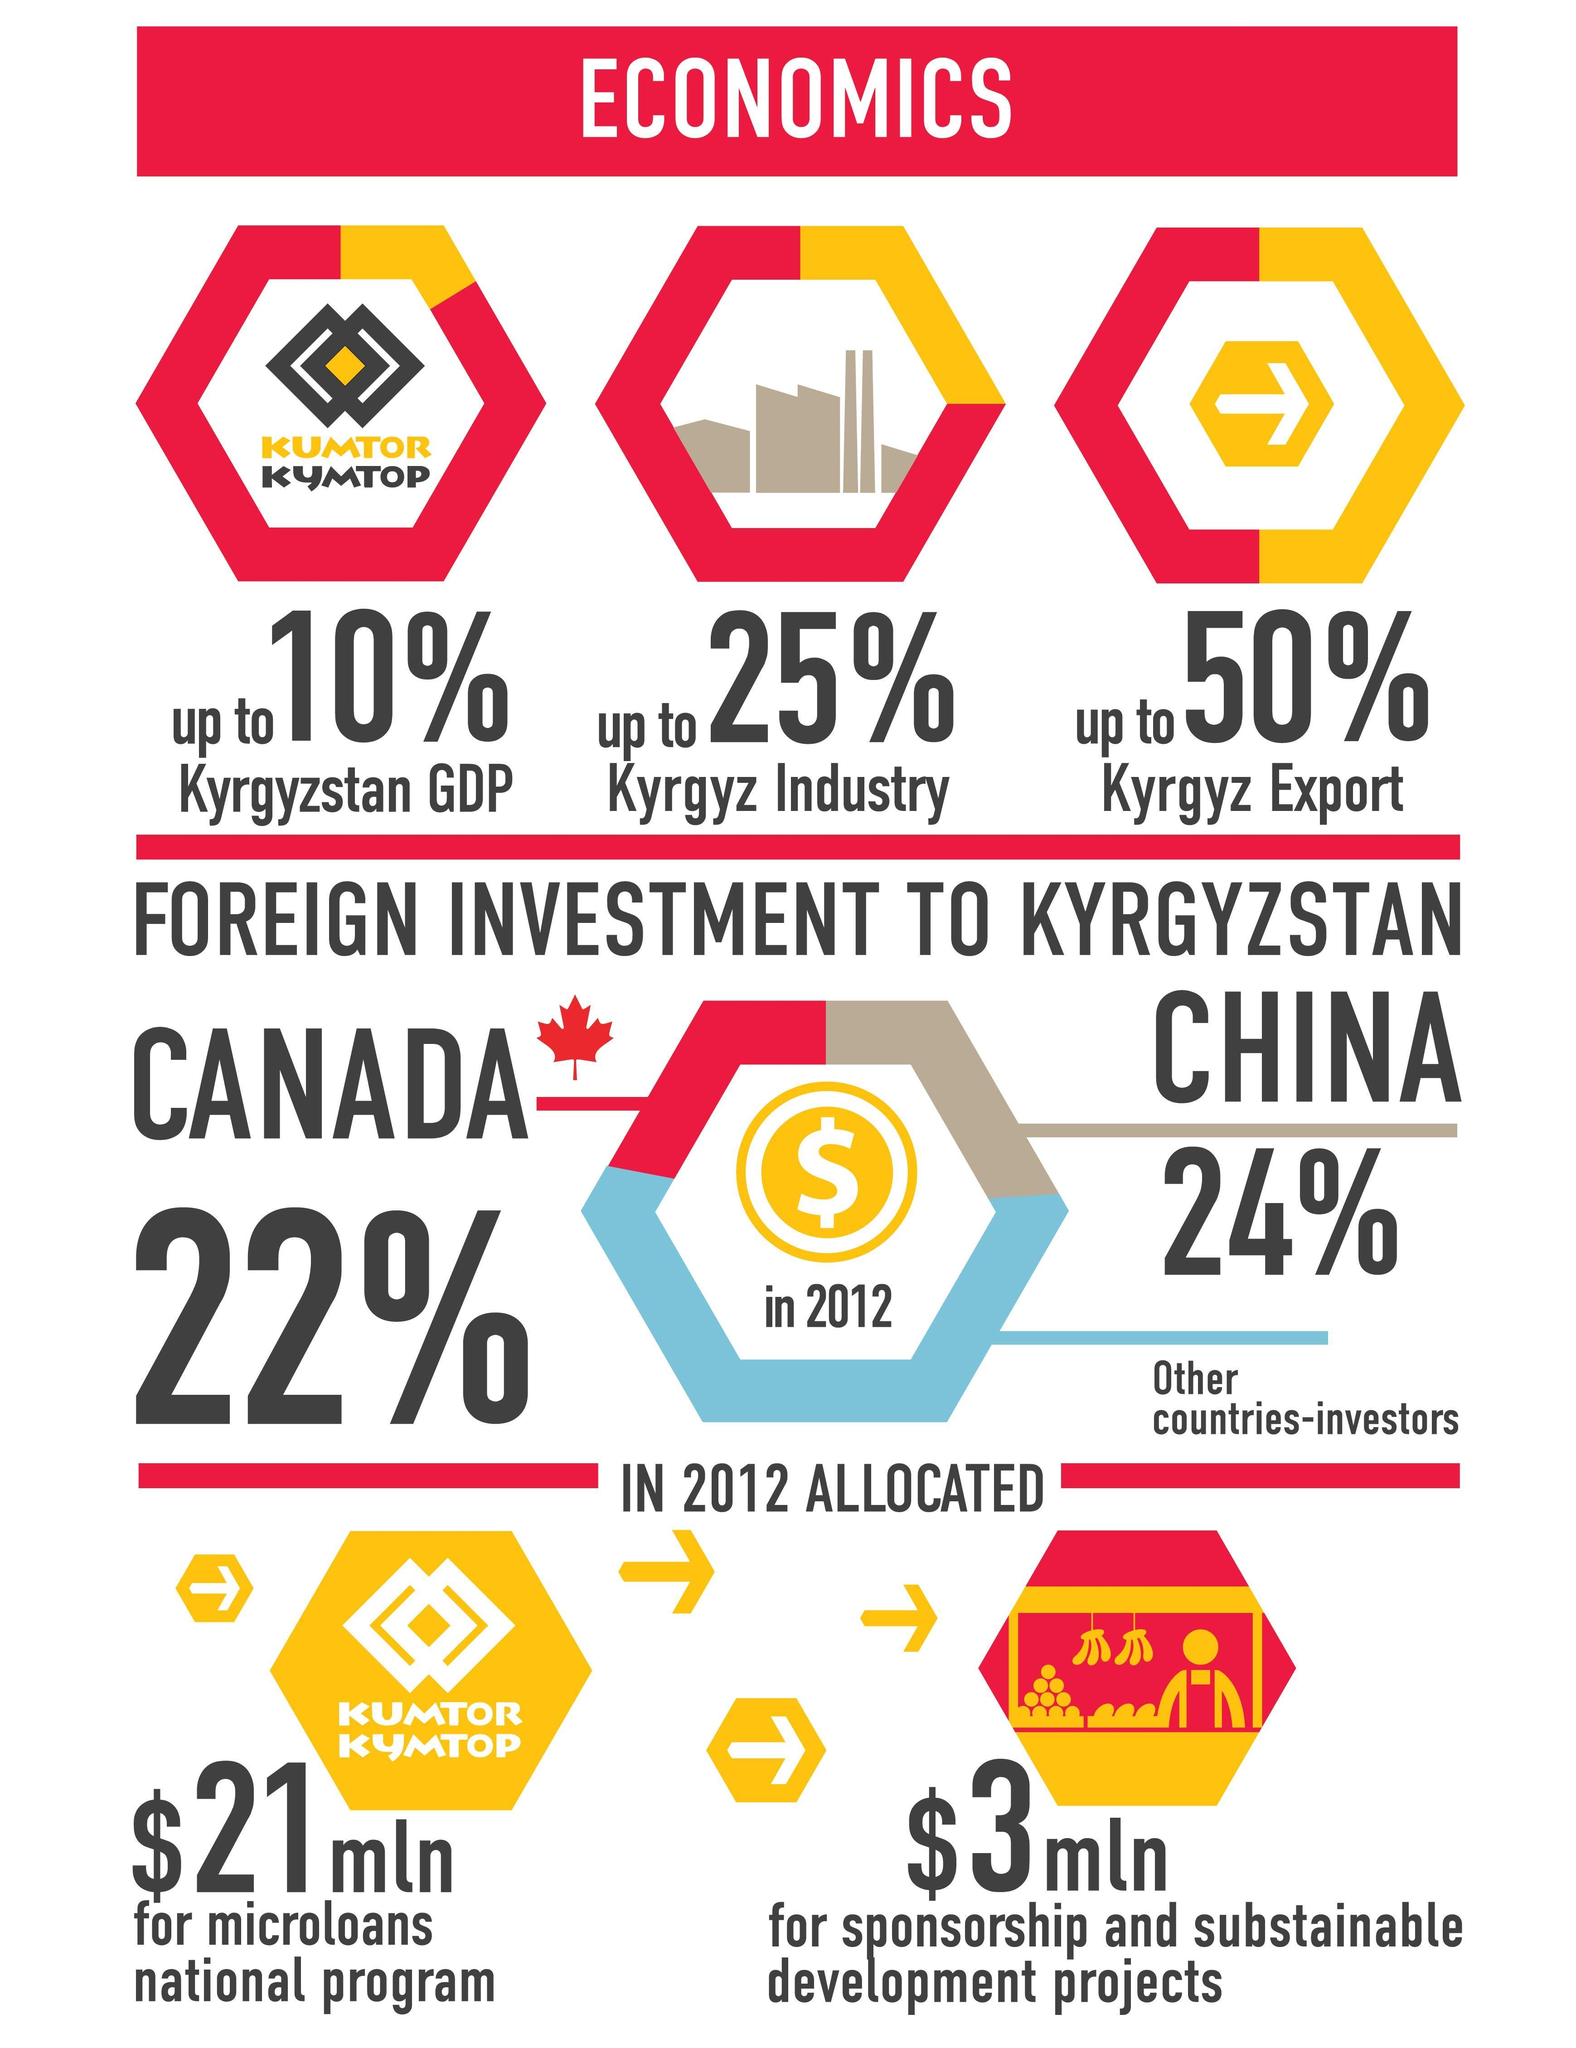List a handful of essential elements in this visual. In 2012, China accounted for approximately 24% of the total foreign investment in Kyrgyzstan. In 2012, it was reported that approximately 50% of the exports made in Kyrgyzstan. In 2012, a total of $3 million was allocated for sponsorship and sustainable development projects in Kyrgyzstan. The microloans national program in Kyrgyzstan was allocated a total of $21 million in 2012. In 2012, Canada accounted for 22% of the total foreign investment in Kyrgyzstan. 